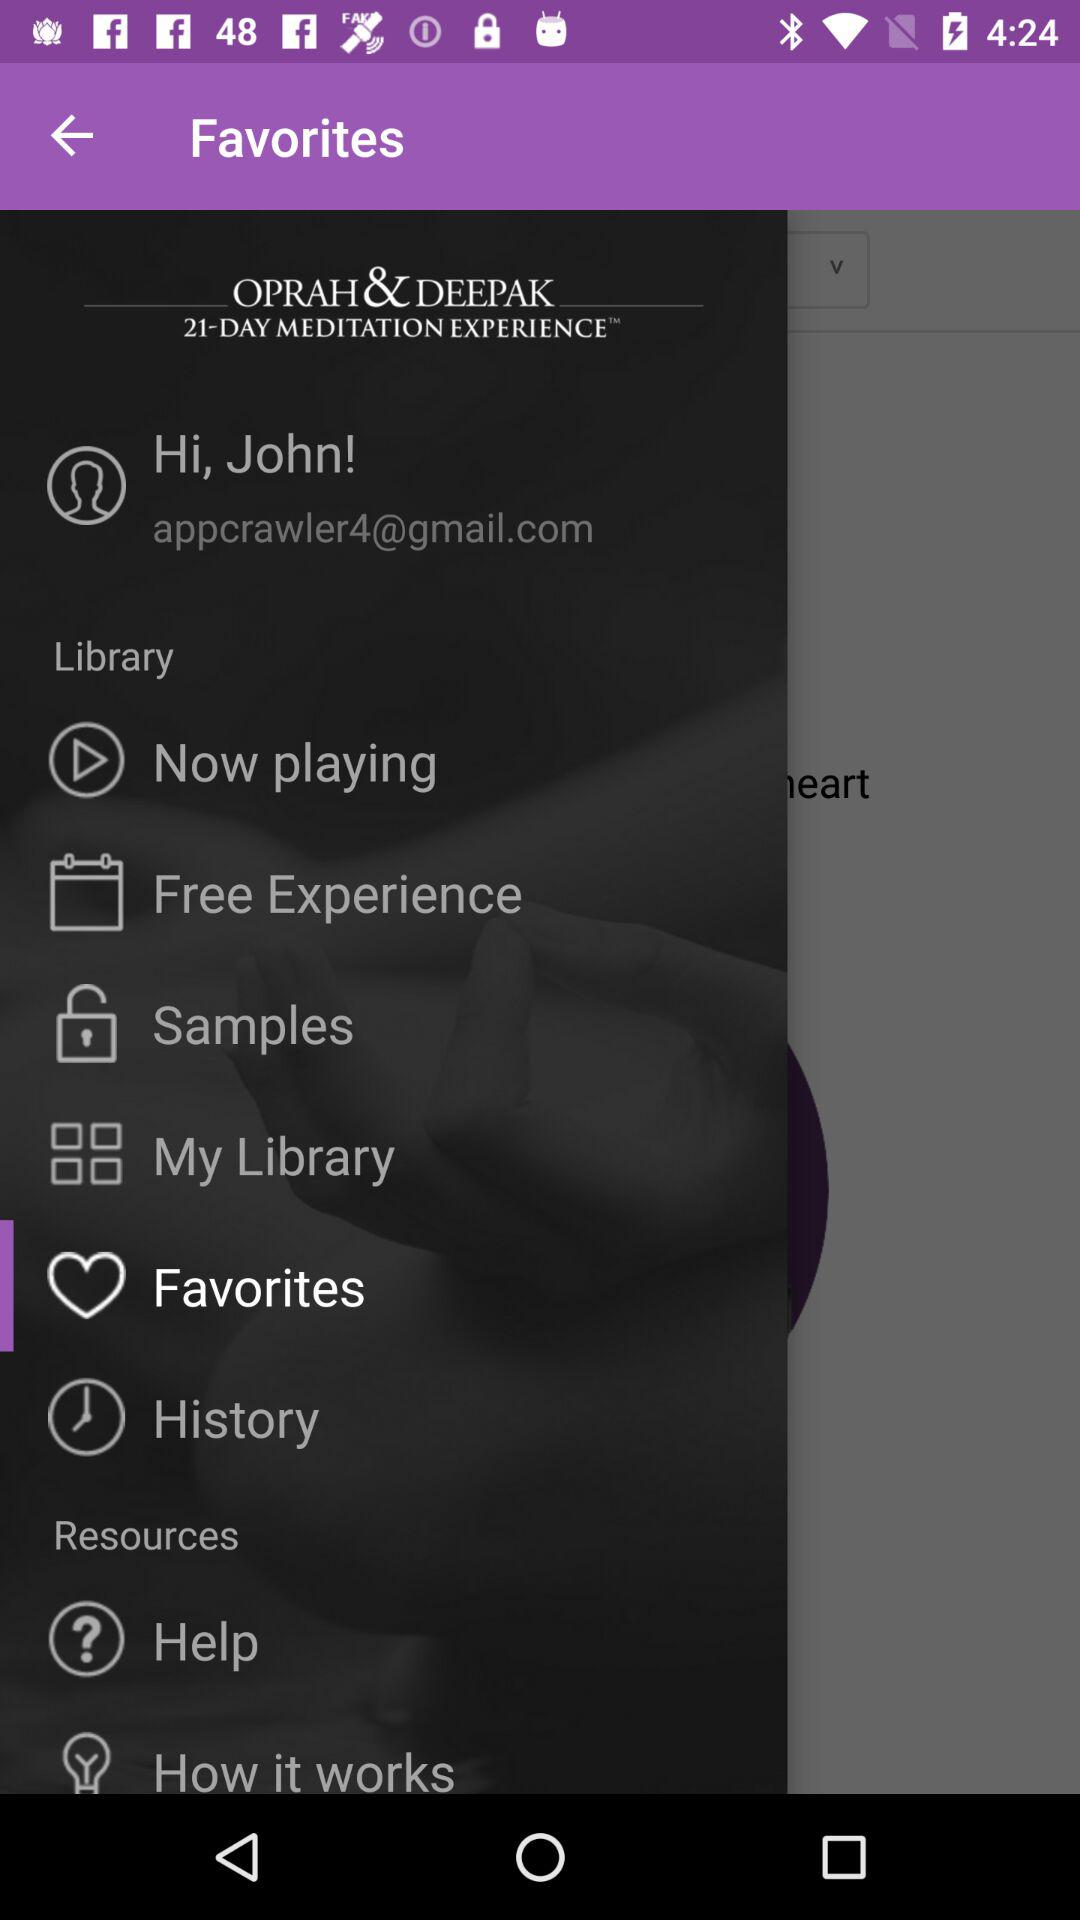What is the email address? The email address is appcrawler4@gmail.com. 